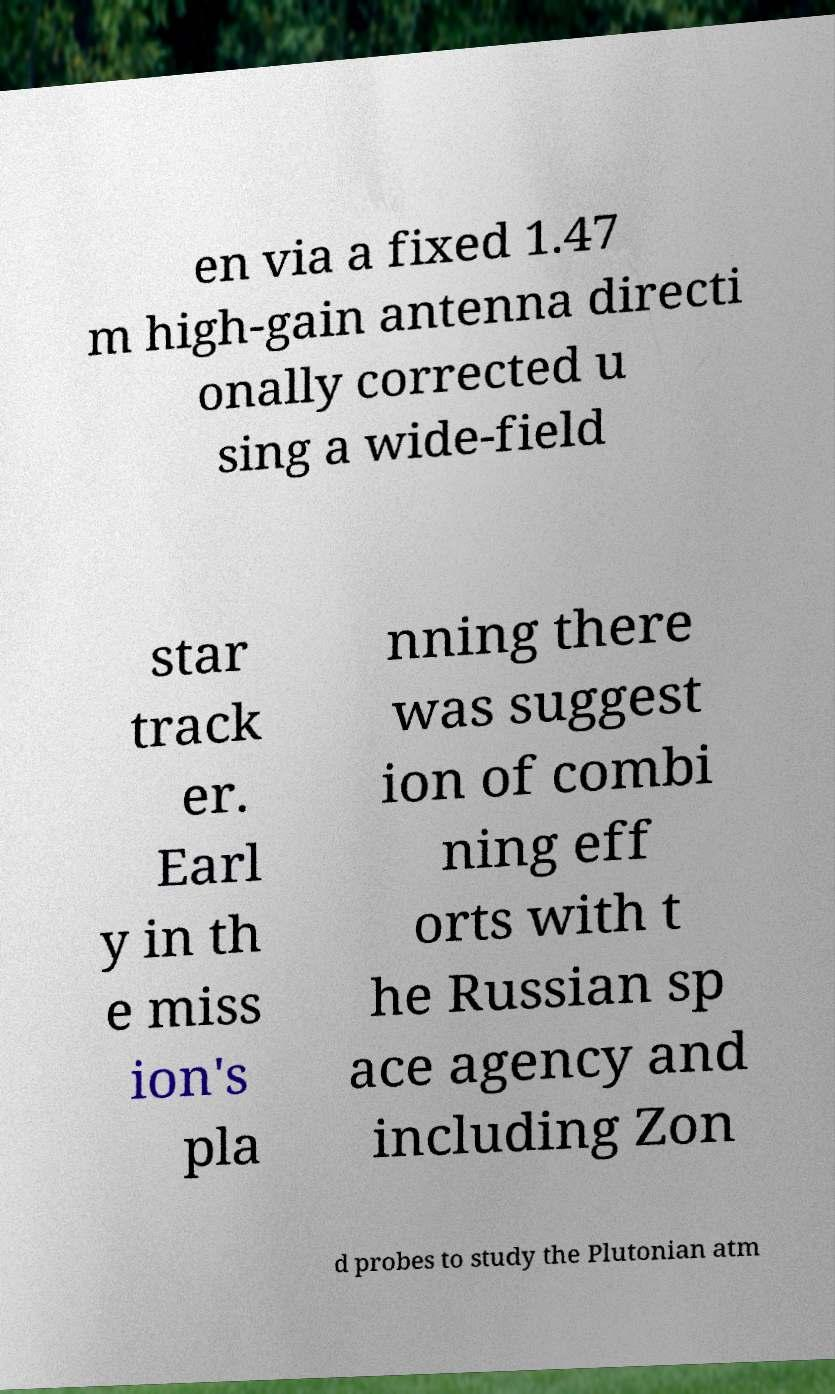There's text embedded in this image that I need extracted. Can you transcribe it verbatim? en via a fixed 1.47 m high-gain antenna directi onally corrected u sing a wide-field star track er. Earl y in th e miss ion's pla nning there was suggest ion of combi ning eff orts with t he Russian sp ace agency and including Zon d probes to study the Plutonian atm 